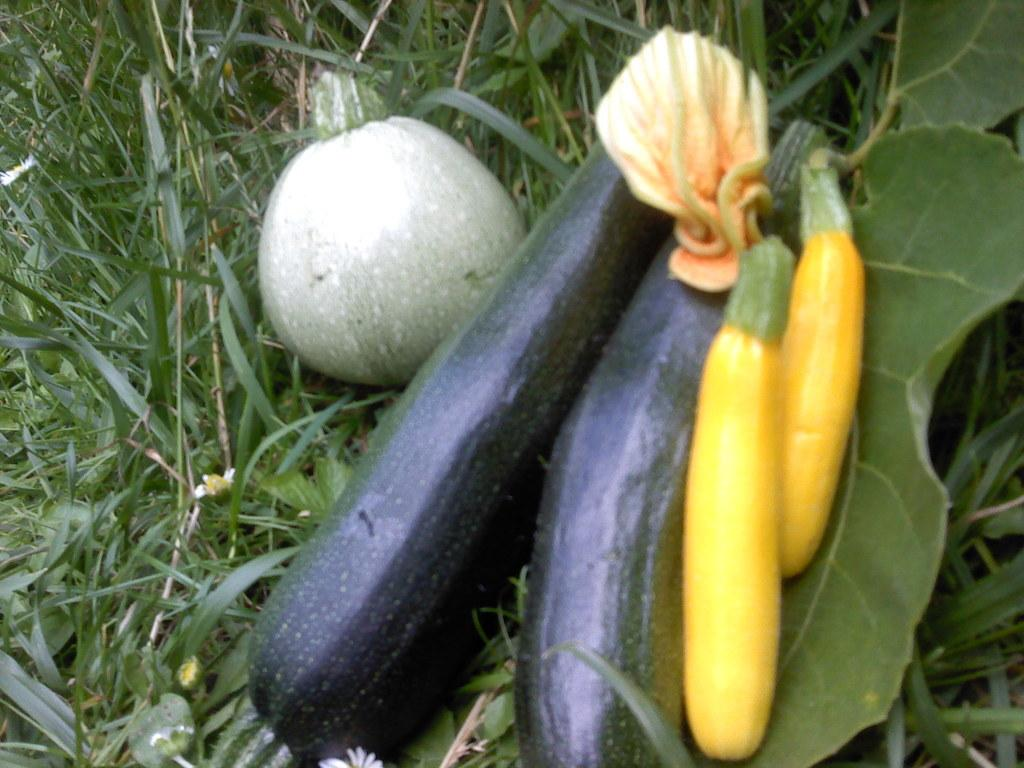What type of food is present in the image? There are vegetables in the image. Can you describe the colors of the vegetables? The vegetables have different colors, including yellow, black, and green. What else can be seen in the background of the image? There are leaves visible in the background of the image. What type of slave is depicted in the image? There is no depiction of a slave in the image; it features vegetables with different colors and leaves in the background. Does the existence of the vegetables in the image prove the existence of life on other planets? The presence of vegetables in the image does not provide any information about the existence of life on other planets. 